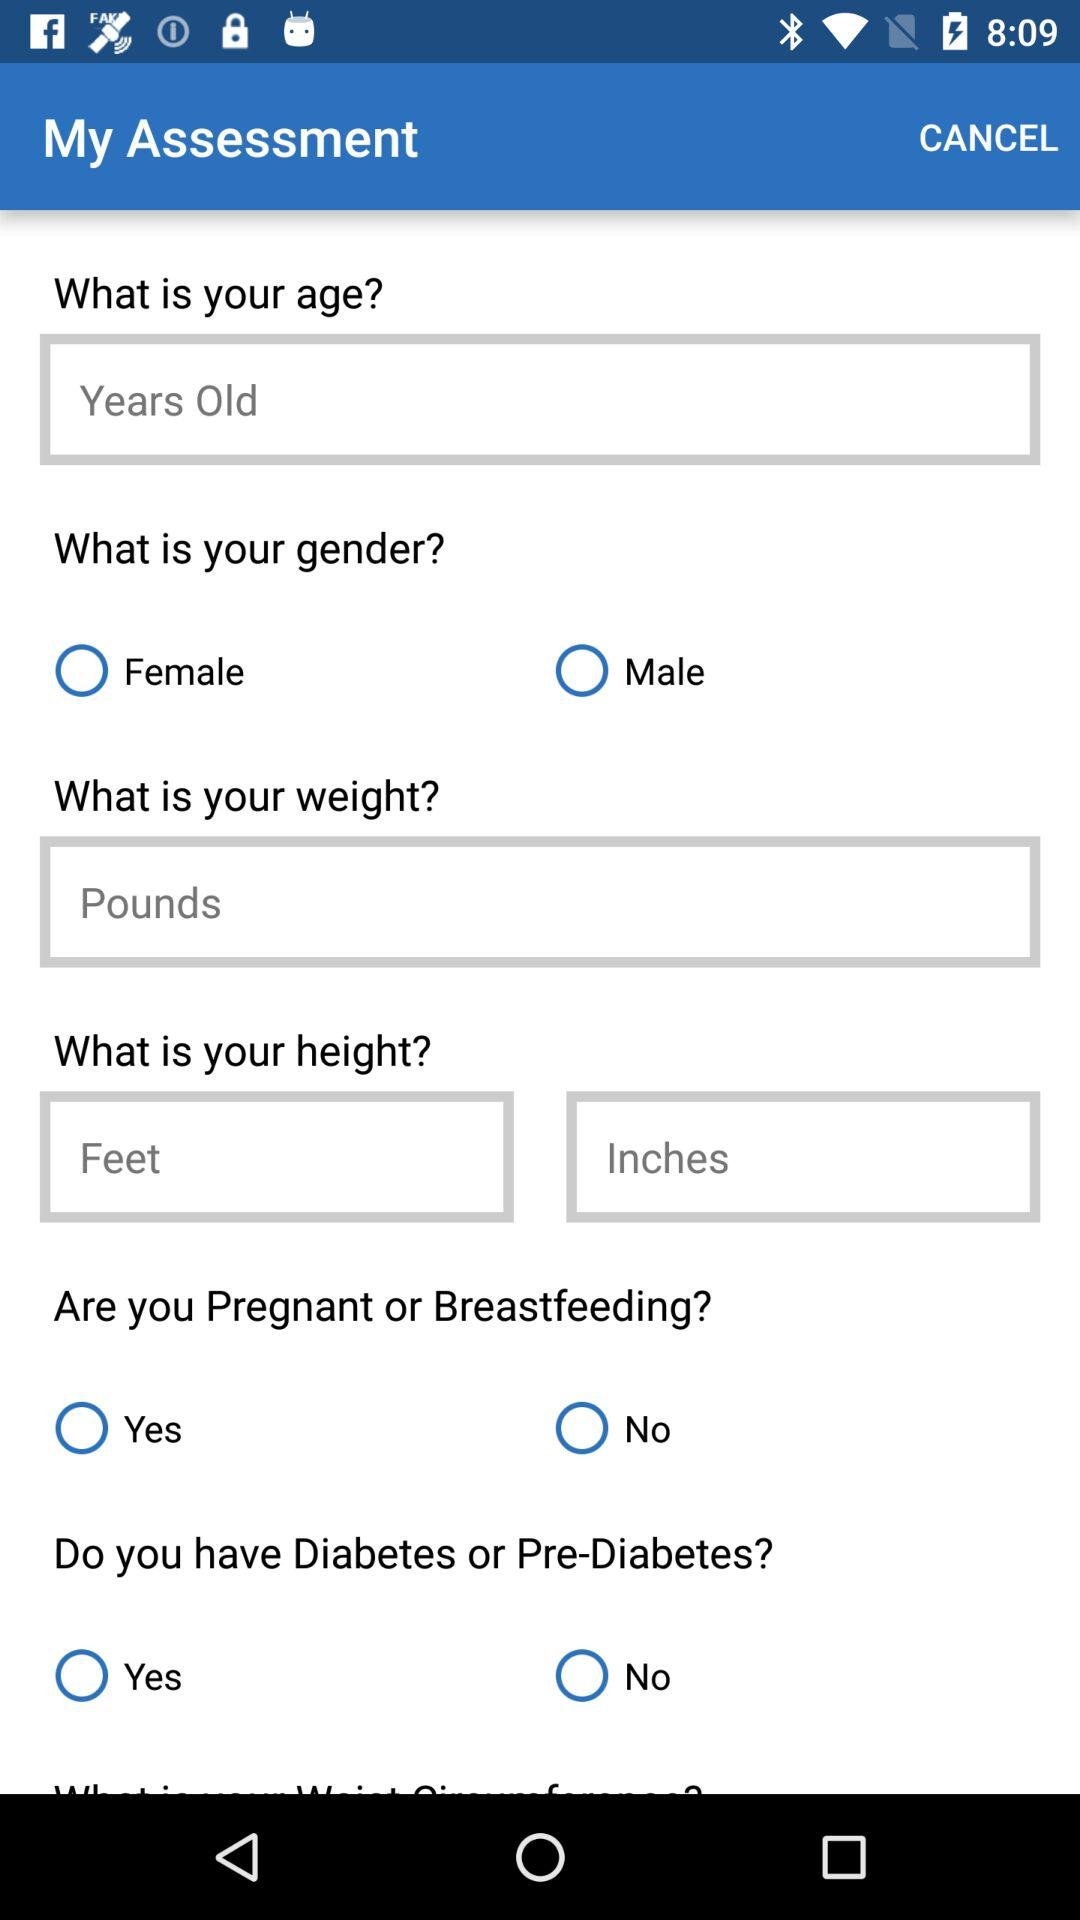How many more text inputs are there for height than for weight?
Answer the question using a single word or phrase. 1 